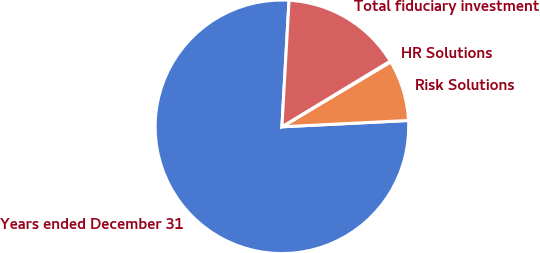Convert chart to OTSL. <chart><loc_0><loc_0><loc_500><loc_500><pie_chart><fcel>Years ended December 31<fcel>Risk Solutions<fcel>HR Solutions<fcel>Total fiduciary investment<nl><fcel>76.69%<fcel>7.77%<fcel>0.11%<fcel>15.43%<nl></chart> 